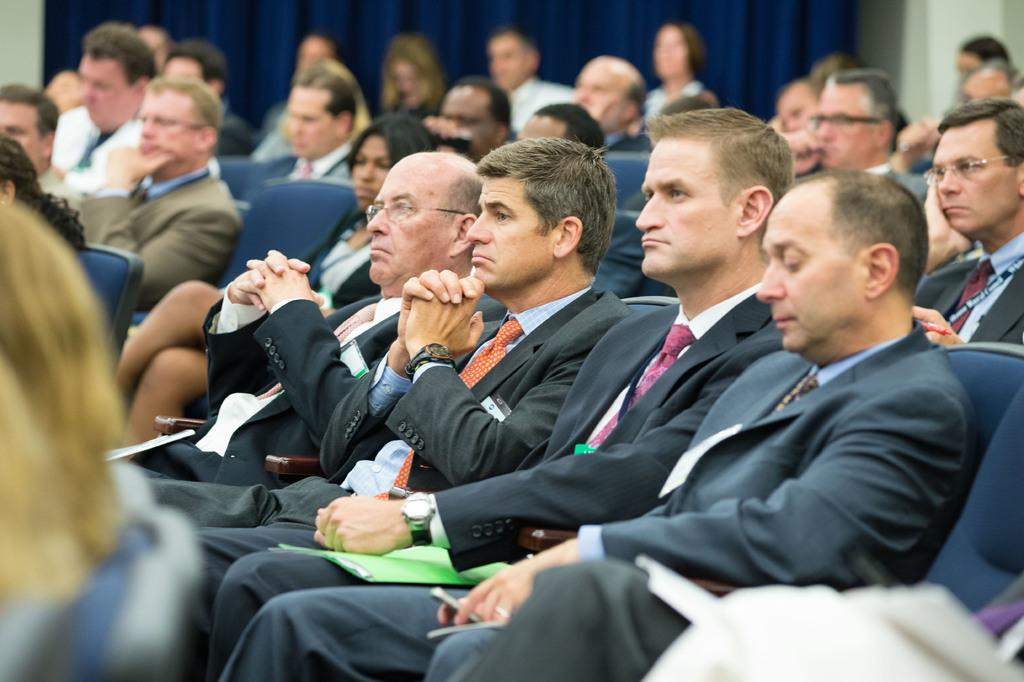What are the people in the image doing? The people in the image are sitting on chairs. What type of clothing are most of the men wearing? Most of the men are wearing suits. What color is the cloth visible in the background of the image? The cloth in the background of the image is blue. How many hands are visible in the image? There is no information about hands in the provided facts, so it cannot be determined from the image. 